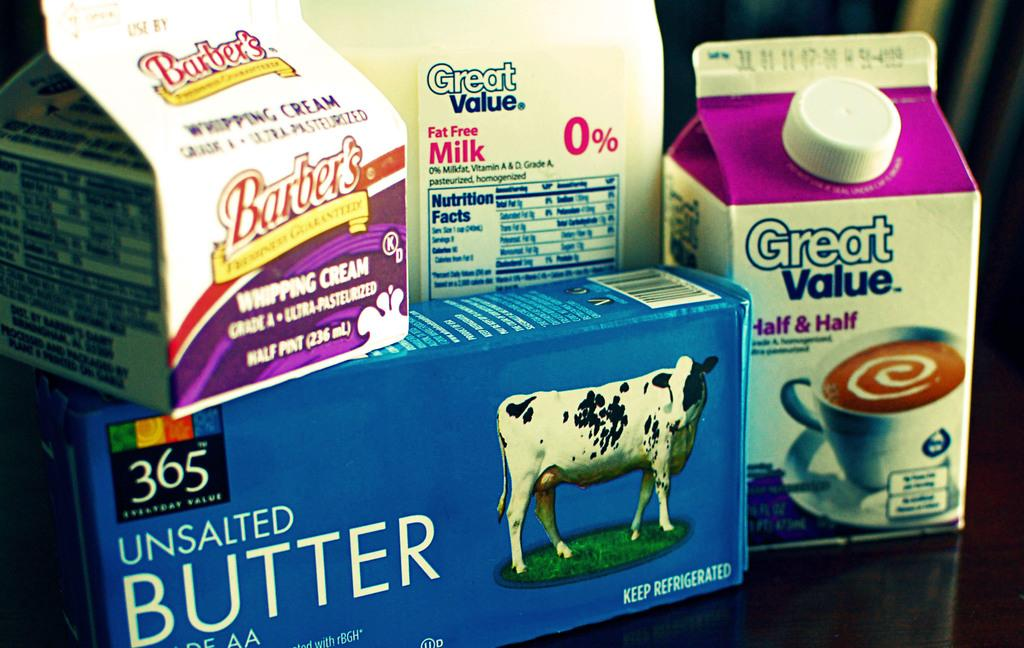What is placed on a surface in the image? There are tetra milk packets placed on a surface in the image. Can you describe the appearance of the milk packets? The milk packets are tetra in shape. What might be the purpose of placing the milk packets on the surface? The milk packets might be placed there for storage or distribution. What type of view can be seen from the sea in the image? There is no sea or view present in the image; it only features tetra milk packets placed on a surface. How many clovers are visible in the image? There are no clovers present in the image. 